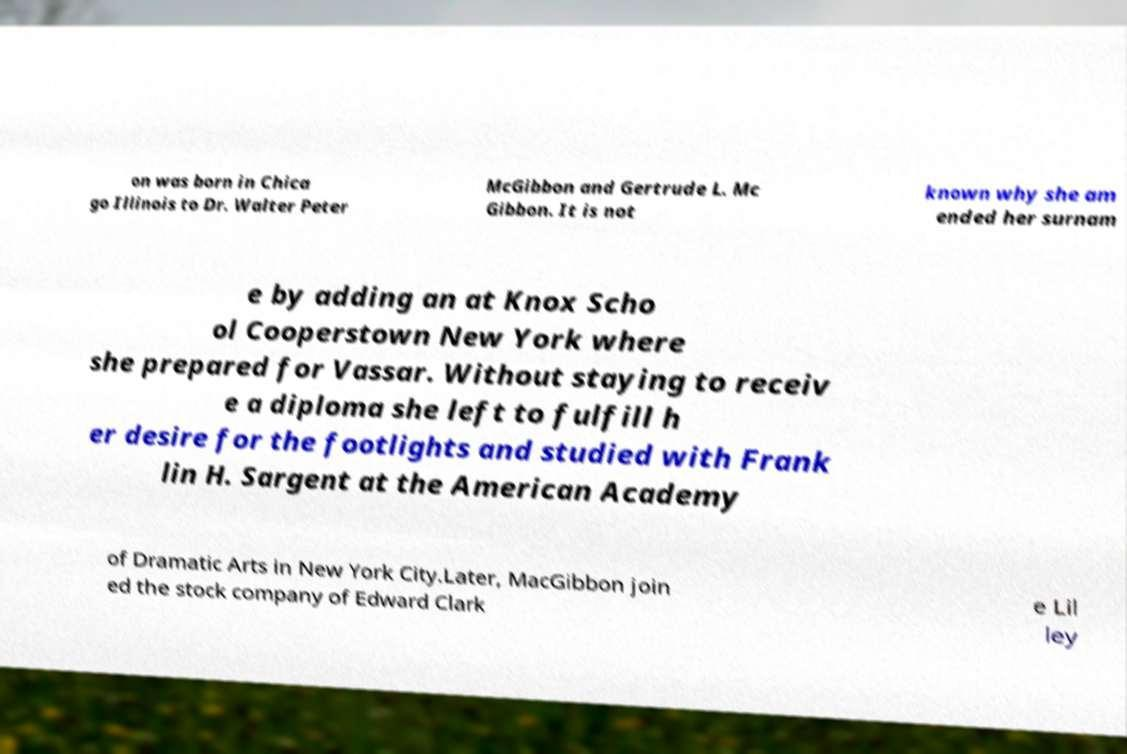Can you read and provide the text displayed in the image?This photo seems to have some interesting text. Can you extract and type it out for me? on was born in Chica go Illinois to Dr. Walter Peter McGibbon and Gertrude L. Mc Gibbon. It is not known why she am ended her surnam e by adding an at Knox Scho ol Cooperstown New York where she prepared for Vassar. Without staying to receiv e a diploma she left to fulfill h er desire for the footlights and studied with Frank lin H. Sargent at the American Academy of Dramatic Arts in New York City.Later, MacGibbon join ed the stock company of Edward Clark e Lil ley 